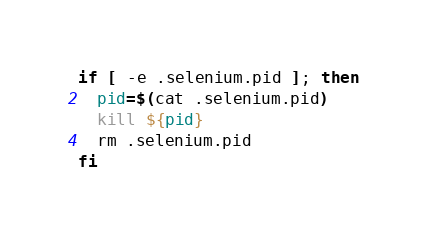<code> <loc_0><loc_0><loc_500><loc_500><_Bash_>if [ -e .selenium.pid ]; then
  pid=$(cat .selenium.pid)
  kill ${pid}
  rm .selenium.pid
fi
</code> 